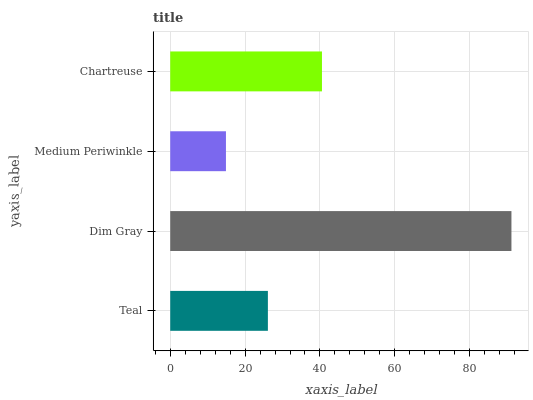Is Medium Periwinkle the minimum?
Answer yes or no. Yes. Is Dim Gray the maximum?
Answer yes or no. Yes. Is Dim Gray the minimum?
Answer yes or no. No. Is Medium Periwinkle the maximum?
Answer yes or no. No. Is Dim Gray greater than Medium Periwinkle?
Answer yes or no. Yes. Is Medium Periwinkle less than Dim Gray?
Answer yes or no. Yes. Is Medium Periwinkle greater than Dim Gray?
Answer yes or no. No. Is Dim Gray less than Medium Periwinkle?
Answer yes or no. No. Is Chartreuse the high median?
Answer yes or no. Yes. Is Teal the low median?
Answer yes or no. Yes. Is Medium Periwinkle the high median?
Answer yes or no. No. Is Chartreuse the low median?
Answer yes or no. No. 